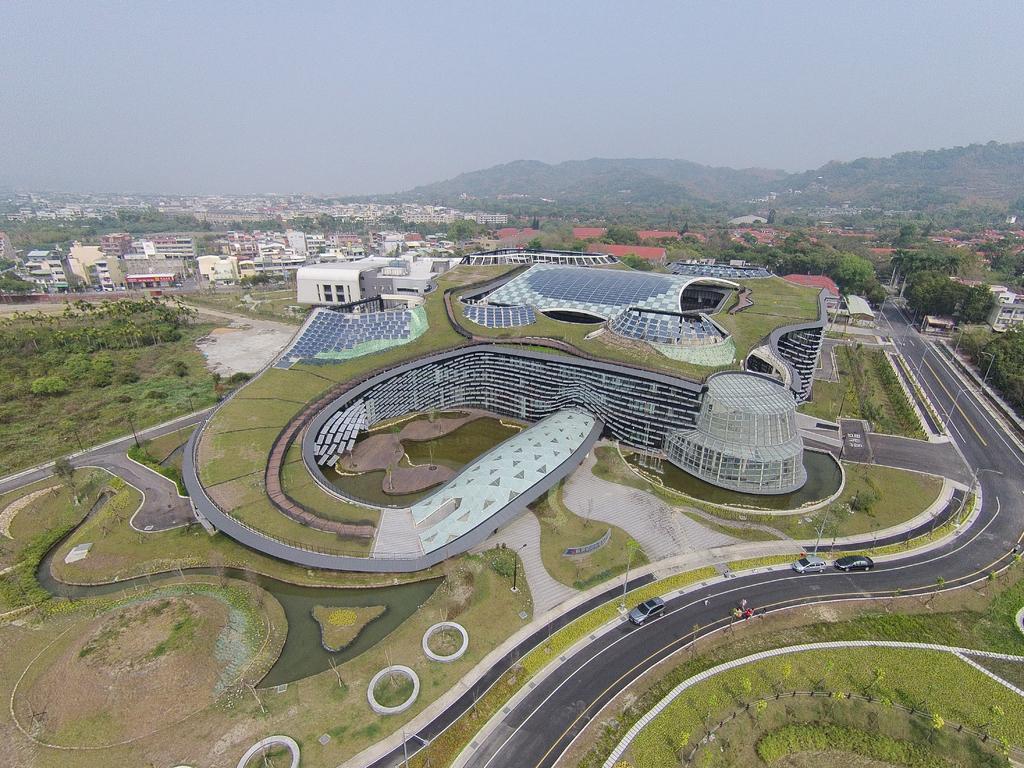Could you give a brief overview of what you see in this image? Right side of the image there are few vehicles on the road. There are few buildings. Right side there is construction on the land. Left bottom there is water in between the land. Left side there are few trees. Right side there is a hill. Top of the image there is sky. 